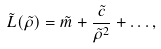Convert formula to latex. <formula><loc_0><loc_0><loc_500><loc_500>\tilde { L } ( \tilde { \rho } ) = \tilde { m } + \frac { \tilde { c } } { \tilde { \rho } ^ { 2 } } + \dots ,</formula> 